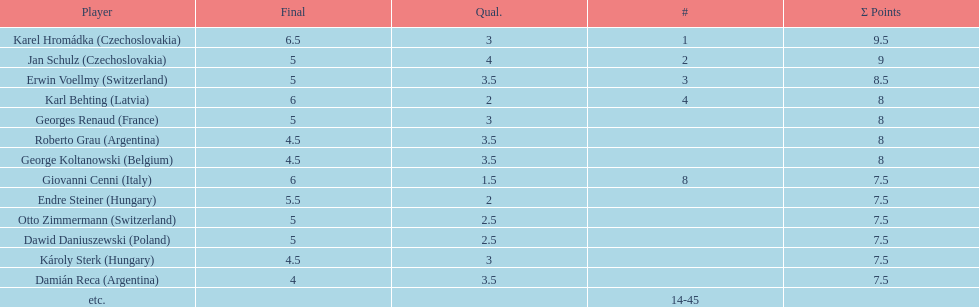How many players tied for 4th place? 4. 